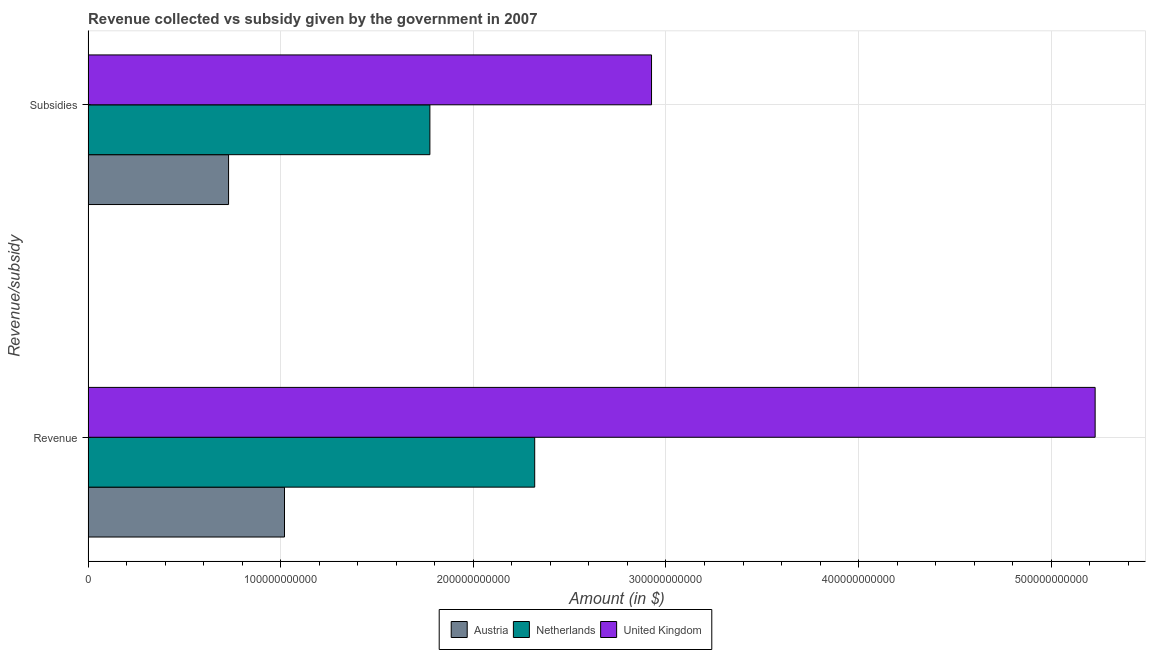How many groups of bars are there?
Offer a terse response. 2. Are the number of bars per tick equal to the number of legend labels?
Your response must be concise. Yes. How many bars are there on the 2nd tick from the top?
Provide a short and direct response. 3. How many bars are there on the 1st tick from the bottom?
Offer a terse response. 3. What is the label of the 2nd group of bars from the top?
Provide a succinct answer. Revenue. What is the amount of revenue collected in United Kingdom?
Offer a terse response. 5.23e+11. Across all countries, what is the maximum amount of subsidies given?
Make the answer very short. 2.93e+11. Across all countries, what is the minimum amount of revenue collected?
Your answer should be compact. 1.02e+11. In which country was the amount of subsidies given minimum?
Provide a short and direct response. Austria. What is the total amount of revenue collected in the graph?
Ensure brevity in your answer.  8.57e+11. What is the difference between the amount of subsidies given in Netherlands and that in United Kingdom?
Provide a short and direct response. -1.15e+11. What is the difference between the amount of subsidies given in Netherlands and the amount of revenue collected in Austria?
Provide a short and direct response. 7.55e+1. What is the average amount of subsidies given per country?
Your answer should be compact. 1.81e+11. What is the difference between the amount of subsidies given and amount of revenue collected in Austria?
Your answer should be compact. -2.90e+1. What is the ratio of the amount of revenue collected in Austria to that in Netherlands?
Provide a short and direct response. 0.44. Is the amount of subsidies given in United Kingdom less than that in Austria?
Your answer should be compact. No. In how many countries, is the amount of subsidies given greater than the average amount of subsidies given taken over all countries?
Ensure brevity in your answer.  1. What does the 1st bar from the top in Subsidies represents?
Ensure brevity in your answer.  United Kingdom. How many bars are there?
Provide a succinct answer. 6. Are all the bars in the graph horizontal?
Keep it short and to the point. Yes. What is the difference between two consecutive major ticks on the X-axis?
Ensure brevity in your answer.  1.00e+11. Are the values on the major ticks of X-axis written in scientific E-notation?
Offer a terse response. No. Does the graph contain any zero values?
Give a very brief answer. No. How many legend labels are there?
Your answer should be compact. 3. How are the legend labels stacked?
Your answer should be very brief. Horizontal. What is the title of the graph?
Ensure brevity in your answer.  Revenue collected vs subsidy given by the government in 2007. What is the label or title of the X-axis?
Your answer should be very brief. Amount (in $). What is the label or title of the Y-axis?
Offer a very short reply. Revenue/subsidy. What is the Amount (in $) of Austria in Revenue?
Ensure brevity in your answer.  1.02e+11. What is the Amount (in $) in Netherlands in Revenue?
Offer a terse response. 2.32e+11. What is the Amount (in $) in United Kingdom in Revenue?
Make the answer very short. 5.23e+11. What is the Amount (in $) in Austria in Subsidies?
Your answer should be very brief. 7.29e+1. What is the Amount (in $) of Netherlands in Subsidies?
Your answer should be very brief. 1.77e+11. What is the Amount (in $) in United Kingdom in Subsidies?
Your answer should be compact. 2.93e+11. Across all Revenue/subsidy, what is the maximum Amount (in $) of Austria?
Your response must be concise. 1.02e+11. Across all Revenue/subsidy, what is the maximum Amount (in $) in Netherlands?
Offer a very short reply. 2.32e+11. Across all Revenue/subsidy, what is the maximum Amount (in $) in United Kingdom?
Your response must be concise. 5.23e+11. Across all Revenue/subsidy, what is the minimum Amount (in $) of Austria?
Keep it short and to the point. 7.29e+1. Across all Revenue/subsidy, what is the minimum Amount (in $) of Netherlands?
Your response must be concise. 1.77e+11. Across all Revenue/subsidy, what is the minimum Amount (in $) in United Kingdom?
Offer a very short reply. 2.93e+11. What is the total Amount (in $) in Austria in the graph?
Provide a short and direct response. 1.75e+11. What is the total Amount (in $) in Netherlands in the graph?
Provide a short and direct response. 4.09e+11. What is the total Amount (in $) in United Kingdom in the graph?
Make the answer very short. 8.15e+11. What is the difference between the Amount (in $) in Austria in Revenue and that in Subsidies?
Your answer should be very brief. 2.90e+1. What is the difference between the Amount (in $) of Netherlands in Revenue and that in Subsidies?
Keep it short and to the point. 5.44e+1. What is the difference between the Amount (in $) of United Kingdom in Revenue and that in Subsidies?
Ensure brevity in your answer.  2.30e+11. What is the difference between the Amount (in $) in Austria in Revenue and the Amount (in $) in Netherlands in Subsidies?
Provide a short and direct response. -7.55e+1. What is the difference between the Amount (in $) of Austria in Revenue and the Amount (in $) of United Kingdom in Subsidies?
Provide a short and direct response. -1.91e+11. What is the difference between the Amount (in $) of Netherlands in Revenue and the Amount (in $) of United Kingdom in Subsidies?
Provide a short and direct response. -6.07e+1. What is the average Amount (in $) of Austria per Revenue/subsidy?
Provide a succinct answer. 8.74e+1. What is the average Amount (in $) in Netherlands per Revenue/subsidy?
Your answer should be very brief. 2.05e+11. What is the average Amount (in $) of United Kingdom per Revenue/subsidy?
Offer a terse response. 4.08e+11. What is the difference between the Amount (in $) of Austria and Amount (in $) of Netherlands in Revenue?
Ensure brevity in your answer.  -1.30e+11. What is the difference between the Amount (in $) in Austria and Amount (in $) in United Kingdom in Revenue?
Give a very brief answer. -4.21e+11. What is the difference between the Amount (in $) in Netherlands and Amount (in $) in United Kingdom in Revenue?
Offer a terse response. -2.91e+11. What is the difference between the Amount (in $) of Austria and Amount (in $) of Netherlands in Subsidies?
Ensure brevity in your answer.  -1.05e+11. What is the difference between the Amount (in $) in Austria and Amount (in $) in United Kingdom in Subsidies?
Your answer should be very brief. -2.20e+11. What is the difference between the Amount (in $) in Netherlands and Amount (in $) in United Kingdom in Subsidies?
Offer a very short reply. -1.15e+11. What is the ratio of the Amount (in $) of Austria in Revenue to that in Subsidies?
Your answer should be very brief. 1.4. What is the ratio of the Amount (in $) of Netherlands in Revenue to that in Subsidies?
Offer a terse response. 1.31. What is the ratio of the Amount (in $) in United Kingdom in Revenue to that in Subsidies?
Your answer should be compact. 1.79. What is the difference between the highest and the second highest Amount (in $) of Austria?
Make the answer very short. 2.90e+1. What is the difference between the highest and the second highest Amount (in $) of Netherlands?
Your answer should be compact. 5.44e+1. What is the difference between the highest and the second highest Amount (in $) of United Kingdom?
Your answer should be compact. 2.30e+11. What is the difference between the highest and the lowest Amount (in $) in Austria?
Keep it short and to the point. 2.90e+1. What is the difference between the highest and the lowest Amount (in $) in Netherlands?
Provide a succinct answer. 5.44e+1. What is the difference between the highest and the lowest Amount (in $) of United Kingdom?
Your answer should be very brief. 2.30e+11. 